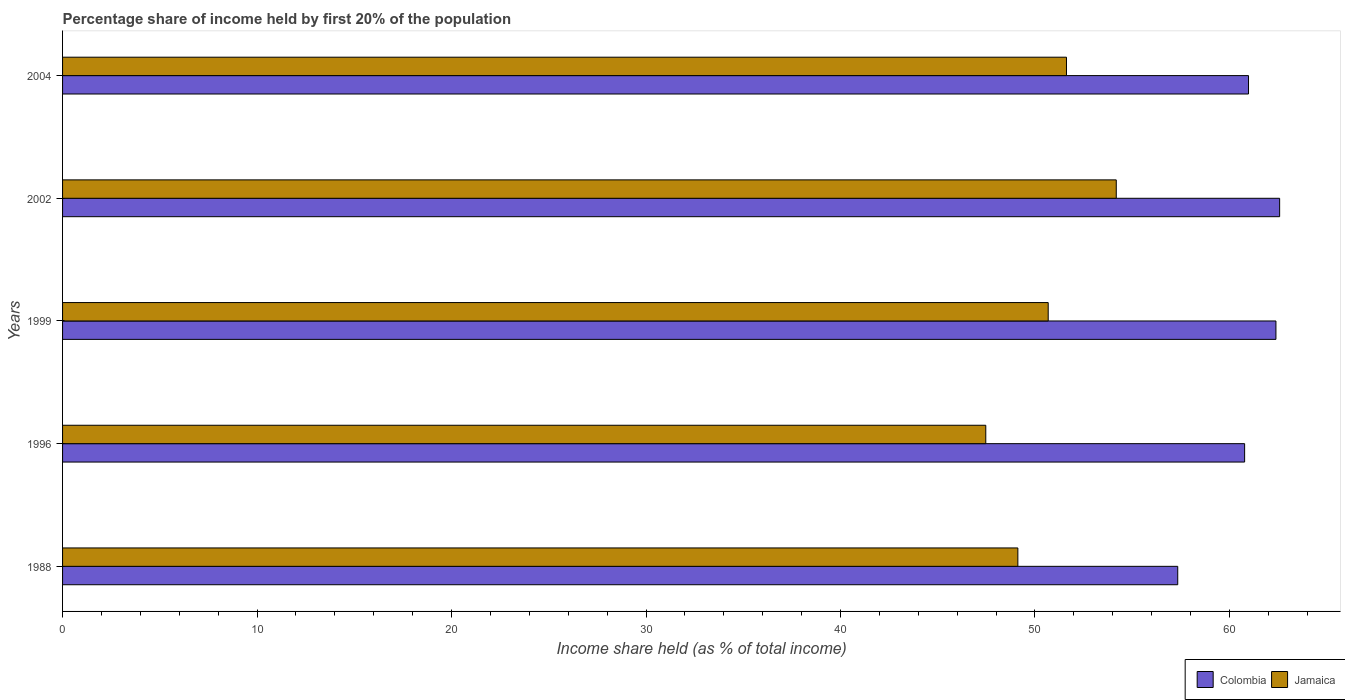How many groups of bars are there?
Your answer should be very brief. 5. Are the number of bars per tick equal to the number of legend labels?
Give a very brief answer. Yes. What is the label of the 5th group of bars from the top?
Offer a terse response. 1988. What is the share of income held by first 20% of the population in Jamaica in 1988?
Your answer should be compact. 49.12. Across all years, what is the maximum share of income held by first 20% of the population in Jamaica?
Give a very brief answer. 54.18. Across all years, what is the minimum share of income held by first 20% of the population in Colombia?
Provide a succinct answer. 57.34. In which year was the share of income held by first 20% of the population in Colombia maximum?
Ensure brevity in your answer.  2002. What is the total share of income held by first 20% of the population in Jamaica in the graph?
Your answer should be very brief. 253.07. What is the difference between the share of income held by first 20% of the population in Colombia in 1996 and that in 2004?
Provide a short and direct response. -0.2. What is the difference between the share of income held by first 20% of the population in Jamaica in 1996 and the share of income held by first 20% of the population in Colombia in 1988?
Offer a very short reply. -9.87. What is the average share of income held by first 20% of the population in Colombia per year?
Keep it short and to the point. 60.81. In the year 1996, what is the difference between the share of income held by first 20% of the population in Colombia and share of income held by first 20% of the population in Jamaica?
Offer a terse response. 13.31. In how many years, is the share of income held by first 20% of the population in Jamaica greater than 30 %?
Provide a succinct answer. 5. What is the ratio of the share of income held by first 20% of the population in Jamaica in 1996 to that in 2002?
Ensure brevity in your answer.  0.88. Is the share of income held by first 20% of the population in Colombia in 2002 less than that in 2004?
Make the answer very short. No. What is the difference between the highest and the second highest share of income held by first 20% of the population in Colombia?
Make the answer very short. 0.19. What is the difference between the highest and the lowest share of income held by first 20% of the population in Jamaica?
Offer a terse response. 6.71. What does the 1st bar from the top in 2004 represents?
Provide a succinct answer. Jamaica. Are all the bars in the graph horizontal?
Provide a succinct answer. Yes. How many years are there in the graph?
Give a very brief answer. 5. What is the difference between two consecutive major ticks on the X-axis?
Your response must be concise. 10. Are the values on the major ticks of X-axis written in scientific E-notation?
Keep it short and to the point. No. Does the graph contain grids?
Keep it short and to the point. No. How are the legend labels stacked?
Your answer should be very brief. Horizontal. What is the title of the graph?
Your answer should be compact. Percentage share of income held by first 20% of the population. What is the label or title of the X-axis?
Ensure brevity in your answer.  Income share held (as % of total income). What is the Income share held (as % of total income) of Colombia in 1988?
Offer a terse response. 57.34. What is the Income share held (as % of total income) of Jamaica in 1988?
Offer a terse response. 49.12. What is the Income share held (as % of total income) of Colombia in 1996?
Your answer should be compact. 60.78. What is the Income share held (as % of total income) in Jamaica in 1996?
Provide a short and direct response. 47.47. What is the Income share held (as % of total income) of Colombia in 1999?
Make the answer very short. 62.39. What is the Income share held (as % of total income) of Jamaica in 1999?
Your answer should be compact. 50.68. What is the Income share held (as % of total income) of Colombia in 2002?
Your answer should be very brief. 62.58. What is the Income share held (as % of total income) of Jamaica in 2002?
Offer a very short reply. 54.18. What is the Income share held (as % of total income) in Colombia in 2004?
Offer a very short reply. 60.98. What is the Income share held (as % of total income) in Jamaica in 2004?
Your answer should be compact. 51.62. Across all years, what is the maximum Income share held (as % of total income) of Colombia?
Give a very brief answer. 62.58. Across all years, what is the maximum Income share held (as % of total income) in Jamaica?
Provide a short and direct response. 54.18. Across all years, what is the minimum Income share held (as % of total income) in Colombia?
Offer a very short reply. 57.34. Across all years, what is the minimum Income share held (as % of total income) of Jamaica?
Provide a short and direct response. 47.47. What is the total Income share held (as % of total income) of Colombia in the graph?
Offer a terse response. 304.07. What is the total Income share held (as % of total income) of Jamaica in the graph?
Your response must be concise. 253.07. What is the difference between the Income share held (as % of total income) in Colombia in 1988 and that in 1996?
Give a very brief answer. -3.44. What is the difference between the Income share held (as % of total income) of Jamaica in 1988 and that in 1996?
Provide a short and direct response. 1.65. What is the difference between the Income share held (as % of total income) in Colombia in 1988 and that in 1999?
Ensure brevity in your answer.  -5.05. What is the difference between the Income share held (as % of total income) in Jamaica in 1988 and that in 1999?
Provide a succinct answer. -1.56. What is the difference between the Income share held (as % of total income) in Colombia in 1988 and that in 2002?
Your answer should be very brief. -5.24. What is the difference between the Income share held (as % of total income) in Jamaica in 1988 and that in 2002?
Your answer should be very brief. -5.06. What is the difference between the Income share held (as % of total income) in Colombia in 1988 and that in 2004?
Ensure brevity in your answer.  -3.64. What is the difference between the Income share held (as % of total income) of Colombia in 1996 and that in 1999?
Provide a short and direct response. -1.61. What is the difference between the Income share held (as % of total income) of Jamaica in 1996 and that in 1999?
Your answer should be very brief. -3.21. What is the difference between the Income share held (as % of total income) of Colombia in 1996 and that in 2002?
Provide a succinct answer. -1.8. What is the difference between the Income share held (as % of total income) of Jamaica in 1996 and that in 2002?
Provide a succinct answer. -6.71. What is the difference between the Income share held (as % of total income) of Jamaica in 1996 and that in 2004?
Keep it short and to the point. -4.15. What is the difference between the Income share held (as % of total income) of Colombia in 1999 and that in 2002?
Ensure brevity in your answer.  -0.19. What is the difference between the Income share held (as % of total income) of Colombia in 1999 and that in 2004?
Offer a very short reply. 1.41. What is the difference between the Income share held (as % of total income) of Jamaica in 1999 and that in 2004?
Keep it short and to the point. -0.94. What is the difference between the Income share held (as % of total income) of Colombia in 2002 and that in 2004?
Your answer should be very brief. 1.6. What is the difference between the Income share held (as % of total income) of Jamaica in 2002 and that in 2004?
Offer a very short reply. 2.56. What is the difference between the Income share held (as % of total income) of Colombia in 1988 and the Income share held (as % of total income) of Jamaica in 1996?
Ensure brevity in your answer.  9.87. What is the difference between the Income share held (as % of total income) in Colombia in 1988 and the Income share held (as % of total income) in Jamaica in 1999?
Ensure brevity in your answer.  6.66. What is the difference between the Income share held (as % of total income) of Colombia in 1988 and the Income share held (as % of total income) of Jamaica in 2002?
Provide a succinct answer. 3.16. What is the difference between the Income share held (as % of total income) in Colombia in 1988 and the Income share held (as % of total income) in Jamaica in 2004?
Make the answer very short. 5.72. What is the difference between the Income share held (as % of total income) of Colombia in 1996 and the Income share held (as % of total income) of Jamaica in 1999?
Your answer should be very brief. 10.1. What is the difference between the Income share held (as % of total income) in Colombia in 1996 and the Income share held (as % of total income) in Jamaica in 2004?
Provide a succinct answer. 9.16. What is the difference between the Income share held (as % of total income) in Colombia in 1999 and the Income share held (as % of total income) in Jamaica in 2002?
Ensure brevity in your answer.  8.21. What is the difference between the Income share held (as % of total income) of Colombia in 1999 and the Income share held (as % of total income) of Jamaica in 2004?
Give a very brief answer. 10.77. What is the difference between the Income share held (as % of total income) of Colombia in 2002 and the Income share held (as % of total income) of Jamaica in 2004?
Your response must be concise. 10.96. What is the average Income share held (as % of total income) of Colombia per year?
Your response must be concise. 60.81. What is the average Income share held (as % of total income) of Jamaica per year?
Make the answer very short. 50.61. In the year 1988, what is the difference between the Income share held (as % of total income) of Colombia and Income share held (as % of total income) of Jamaica?
Make the answer very short. 8.22. In the year 1996, what is the difference between the Income share held (as % of total income) in Colombia and Income share held (as % of total income) in Jamaica?
Offer a terse response. 13.31. In the year 1999, what is the difference between the Income share held (as % of total income) of Colombia and Income share held (as % of total income) of Jamaica?
Your answer should be very brief. 11.71. In the year 2002, what is the difference between the Income share held (as % of total income) of Colombia and Income share held (as % of total income) of Jamaica?
Your answer should be very brief. 8.4. In the year 2004, what is the difference between the Income share held (as % of total income) in Colombia and Income share held (as % of total income) in Jamaica?
Give a very brief answer. 9.36. What is the ratio of the Income share held (as % of total income) of Colombia in 1988 to that in 1996?
Ensure brevity in your answer.  0.94. What is the ratio of the Income share held (as % of total income) of Jamaica in 1988 to that in 1996?
Ensure brevity in your answer.  1.03. What is the ratio of the Income share held (as % of total income) in Colombia in 1988 to that in 1999?
Ensure brevity in your answer.  0.92. What is the ratio of the Income share held (as % of total income) of Jamaica in 1988 to that in 1999?
Your answer should be very brief. 0.97. What is the ratio of the Income share held (as % of total income) in Colombia in 1988 to that in 2002?
Offer a terse response. 0.92. What is the ratio of the Income share held (as % of total income) in Jamaica in 1988 to that in 2002?
Keep it short and to the point. 0.91. What is the ratio of the Income share held (as % of total income) of Colombia in 1988 to that in 2004?
Offer a very short reply. 0.94. What is the ratio of the Income share held (as % of total income) in Jamaica in 1988 to that in 2004?
Your answer should be compact. 0.95. What is the ratio of the Income share held (as % of total income) of Colombia in 1996 to that in 1999?
Offer a terse response. 0.97. What is the ratio of the Income share held (as % of total income) in Jamaica in 1996 to that in 1999?
Provide a succinct answer. 0.94. What is the ratio of the Income share held (as % of total income) in Colombia in 1996 to that in 2002?
Your answer should be compact. 0.97. What is the ratio of the Income share held (as % of total income) of Jamaica in 1996 to that in 2002?
Offer a very short reply. 0.88. What is the ratio of the Income share held (as % of total income) in Colombia in 1996 to that in 2004?
Keep it short and to the point. 1. What is the ratio of the Income share held (as % of total income) of Jamaica in 1996 to that in 2004?
Provide a succinct answer. 0.92. What is the ratio of the Income share held (as % of total income) of Jamaica in 1999 to that in 2002?
Your answer should be compact. 0.94. What is the ratio of the Income share held (as % of total income) in Colombia in 1999 to that in 2004?
Provide a succinct answer. 1.02. What is the ratio of the Income share held (as % of total income) in Jamaica in 1999 to that in 2004?
Offer a very short reply. 0.98. What is the ratio of the Income share held (as % of total income) in Colombia in 2002 to that in 2004?
Offer a very short reply. 1.03. What is the ratio of the Income share held (as % of total income) in Jamaica in 2002 to that in 2004?
Your answer should be very brief. 1.05. What is the difference between the highest and the second highest Income share held (as % of total income) of Colombia?
Offer a terse response. 0.19. What is the difference between the highest and the second highest Income share held (as % of total income) in Jamaica?
Make the answer very short. 2.56. What is the difference between the highest and the lowest Income share held (as % of total income) in Colombia?
Offer a terse response. 5.24. What is the difference between the highest and the lowest Income share held (as % of total income) in Jamaica?
Ensure brevity in your answer.  6.71. 